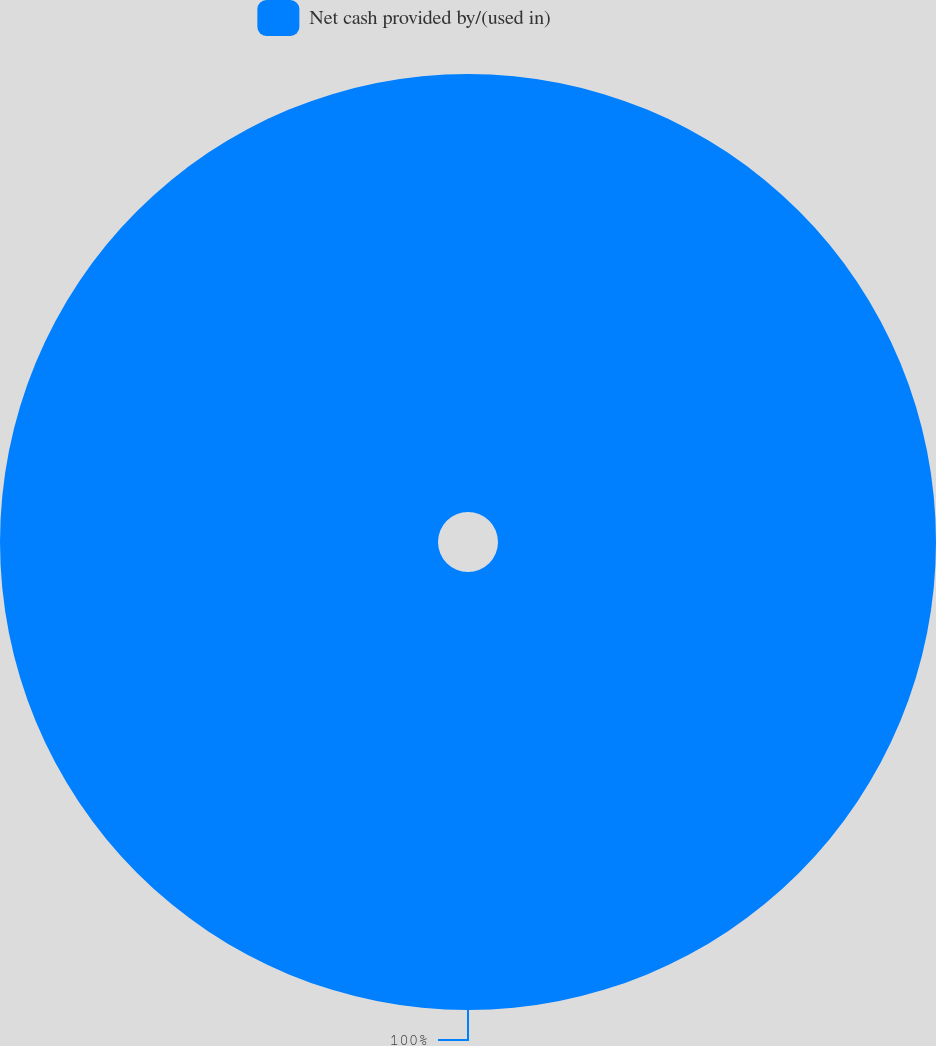Convert chart. <chart><loc_0><loc_0><loc_500><loc_500><pie_chart><fcel>Net cash provided by/(used in)<nl><fcel>100.0%<nl></chart> 